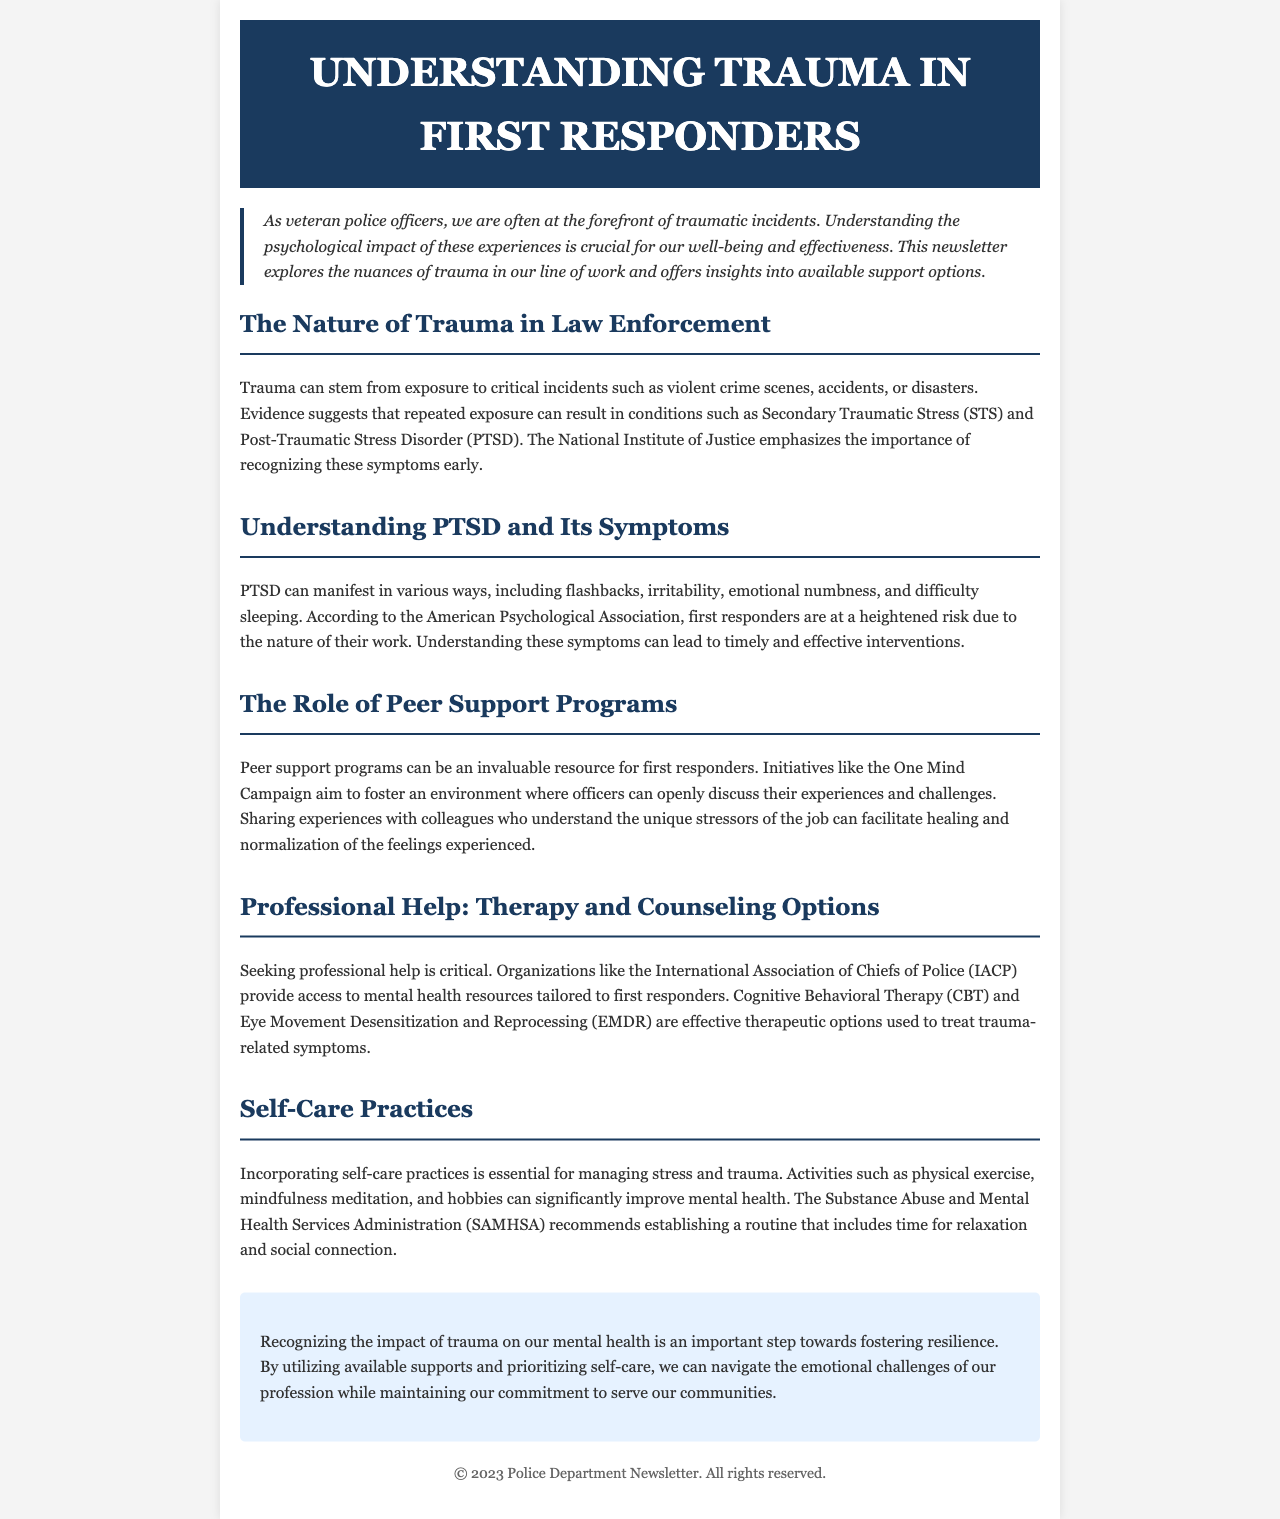What is the title of the newsletter? The title is prominently displayed in the header section of the document.
Answer: Understanding Trauma in First Responders What does PTSD stand for? The acronym is explained in the section addressing its symptoms and is a central part of trauma discussions.
Answer: Post-Traumatic Stress Disorder Which campaign aims to support peer discussions among officers? The initiative is specifically identified in the section about peer support programs as promoting open dialogue.
Answer: One Mind Campaign What therapy is mentioned as a treatment option for trauma-related symptoms? This form of therapy is listed in the section discussing professional help available for first responders.
Answer: Cognitive Behavioral Therapy What organization provides access to mental health resources tailored for first responders? The organization identified in the document serves as a resource for mental health support.
Answer: International Association of Chiefs of Police What is one self-care practice suggested in the newsletter? The document highlights various self-care strategies, emphasizing their importance for mental health management.
Answer: Mindfulness meditation How does the newsletter suggest first responders can improve their mental health? The section on self-care practices outlines strategies for better mental health, suggesting different activities.
Answer: Incorporating self-care practices What color is used for the section headings? The text color of the section headings is mentioned in the styling details of the document.
Answer: #1a3a5e What is emphasized as an important step towards fostering resilience? The conclusion highlights the significance of recognizing trauma's impact on mental health for resilience.
Answer: Recognizing the impact of trauma 